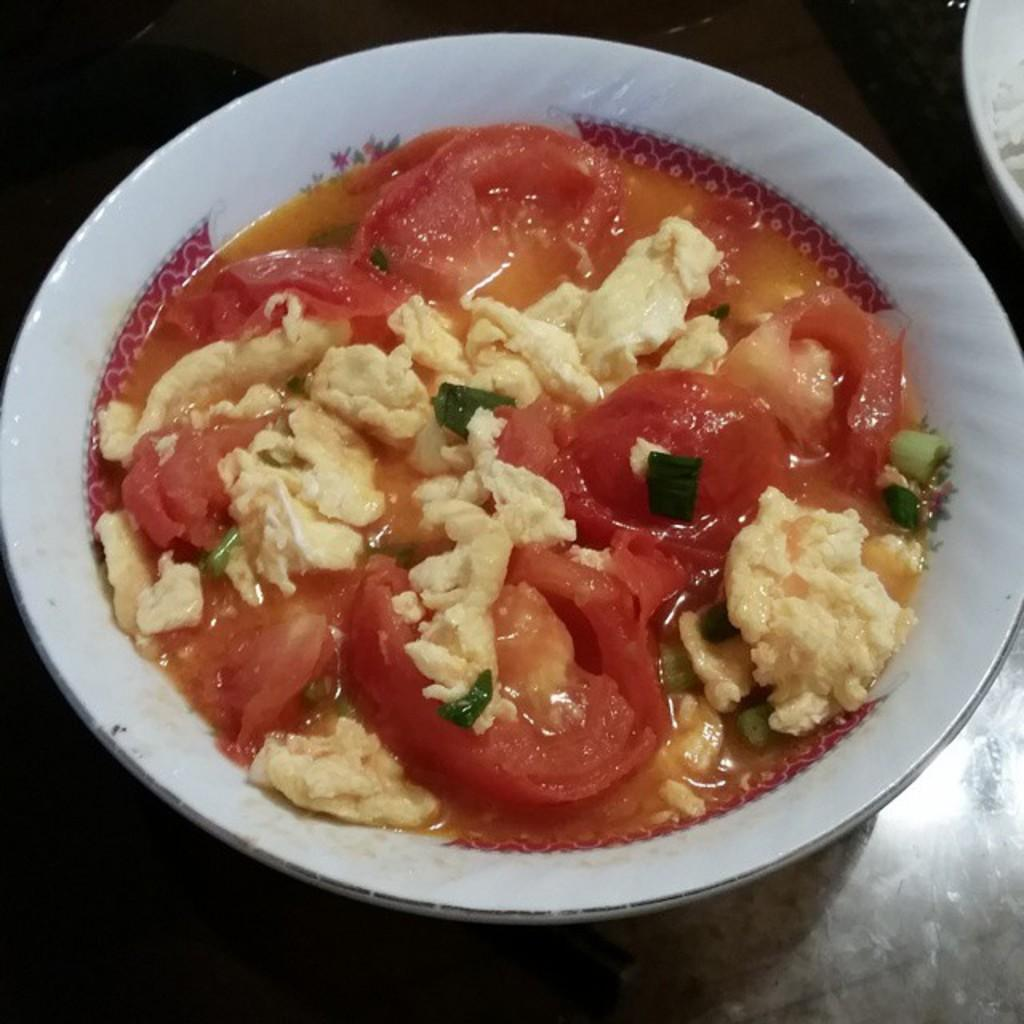What type of soup is in the bowl in the image? There is vegetable soup in a bowl in the image. What is the color of the surface the bowl is on? The bowl is on a black surface. Can you describe the object in the top right corner of the image? There is a white object in the top right corner of the image. What decisions is the committee making about the soup in the image? There is no committee present in the image, and therefore no decisions are being made about the soup. 